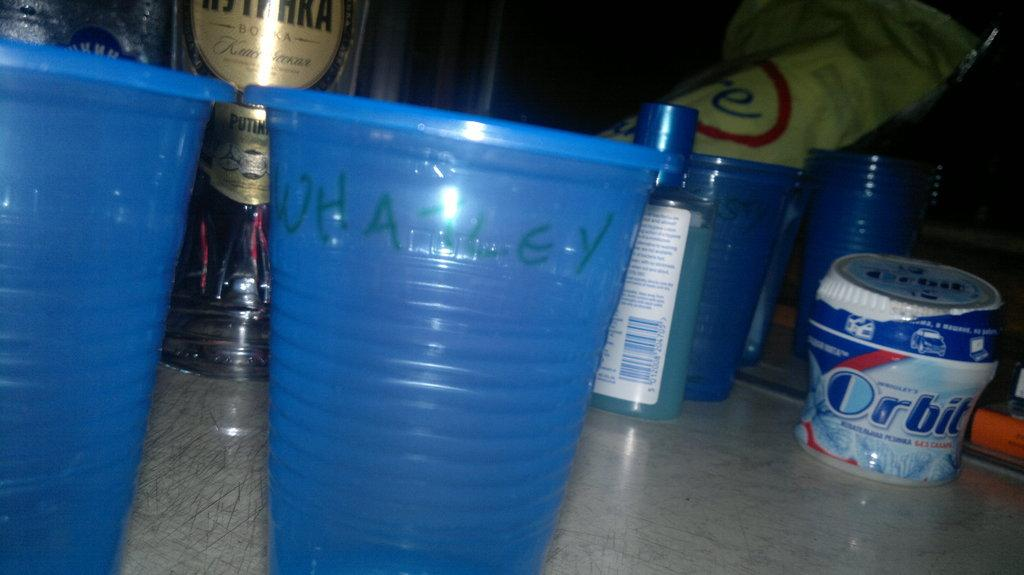<image>
Offer a succinct explanation of the picture presented. A disposable blue plastic cup with the name Whatley written in green marker. 